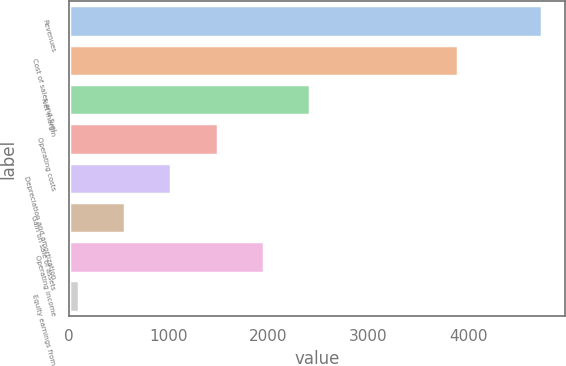Convert chart to OTSL. <chart><loc_0><loc_0><loc_500><loc_500><bar_chart><fcel>Revenues<fcel>Cost of sales and fuel<fcel>Net margin<fcel>Operating costs<fcel>Depreciation and amortization<fcel>Gain on sale of assets<fcel>Operating income<fcel>Equity earnings from<nl><fcel>4738.2<fcel>3894.7<fcel>2417.05<fcel>1488.59<fcel>1024.36<fcel>560.13<fcel>1952.82<fcel>95.9<nl></chart> 